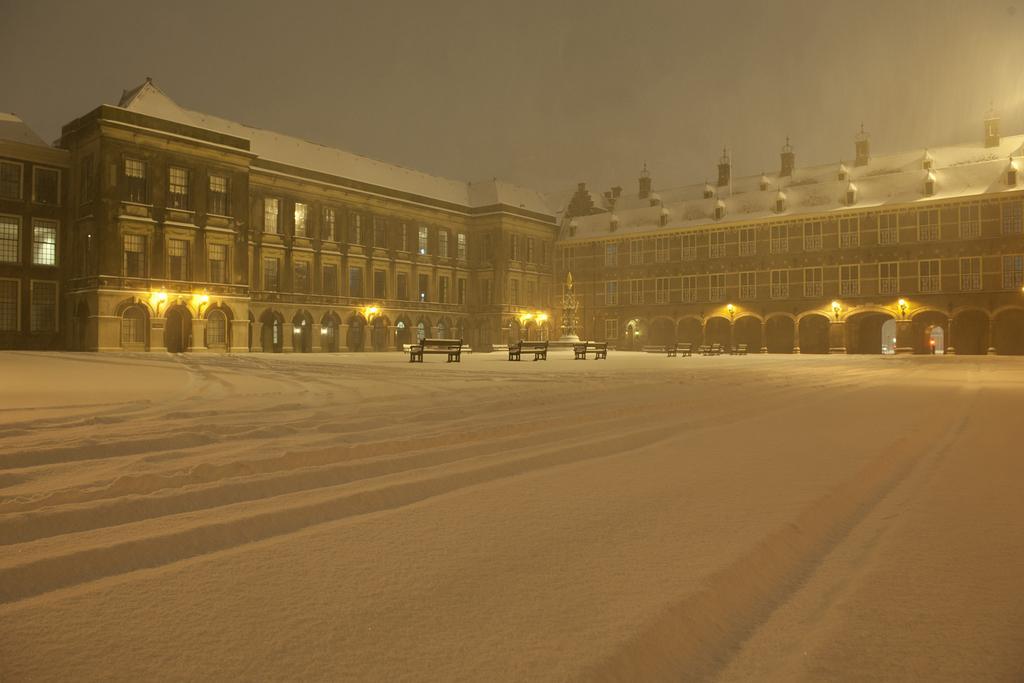Could you give a brief overview of what you see in this image? In this image I can see few benches, background I can see the building in brown and white color. I can also see few lights and the sky is in white and blue color. 